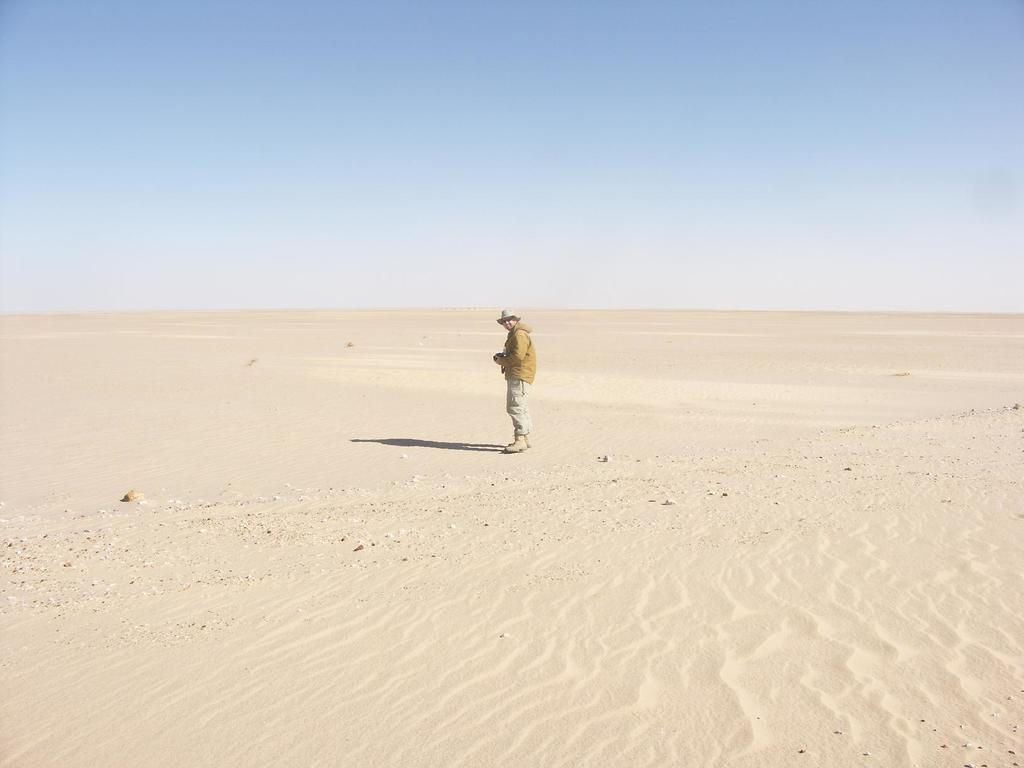What is the main subject of the image? There is a person standing on the ground in the image. What can be seen beneath the person's feet? The ground is visible in the image. What is visible in the background of the image? The sky is visible in the background of the image. What type of breakfast is the person eating in the image? There is no breakfast present in the image; it only features a person standing on the ground with the sky visible in the background. 